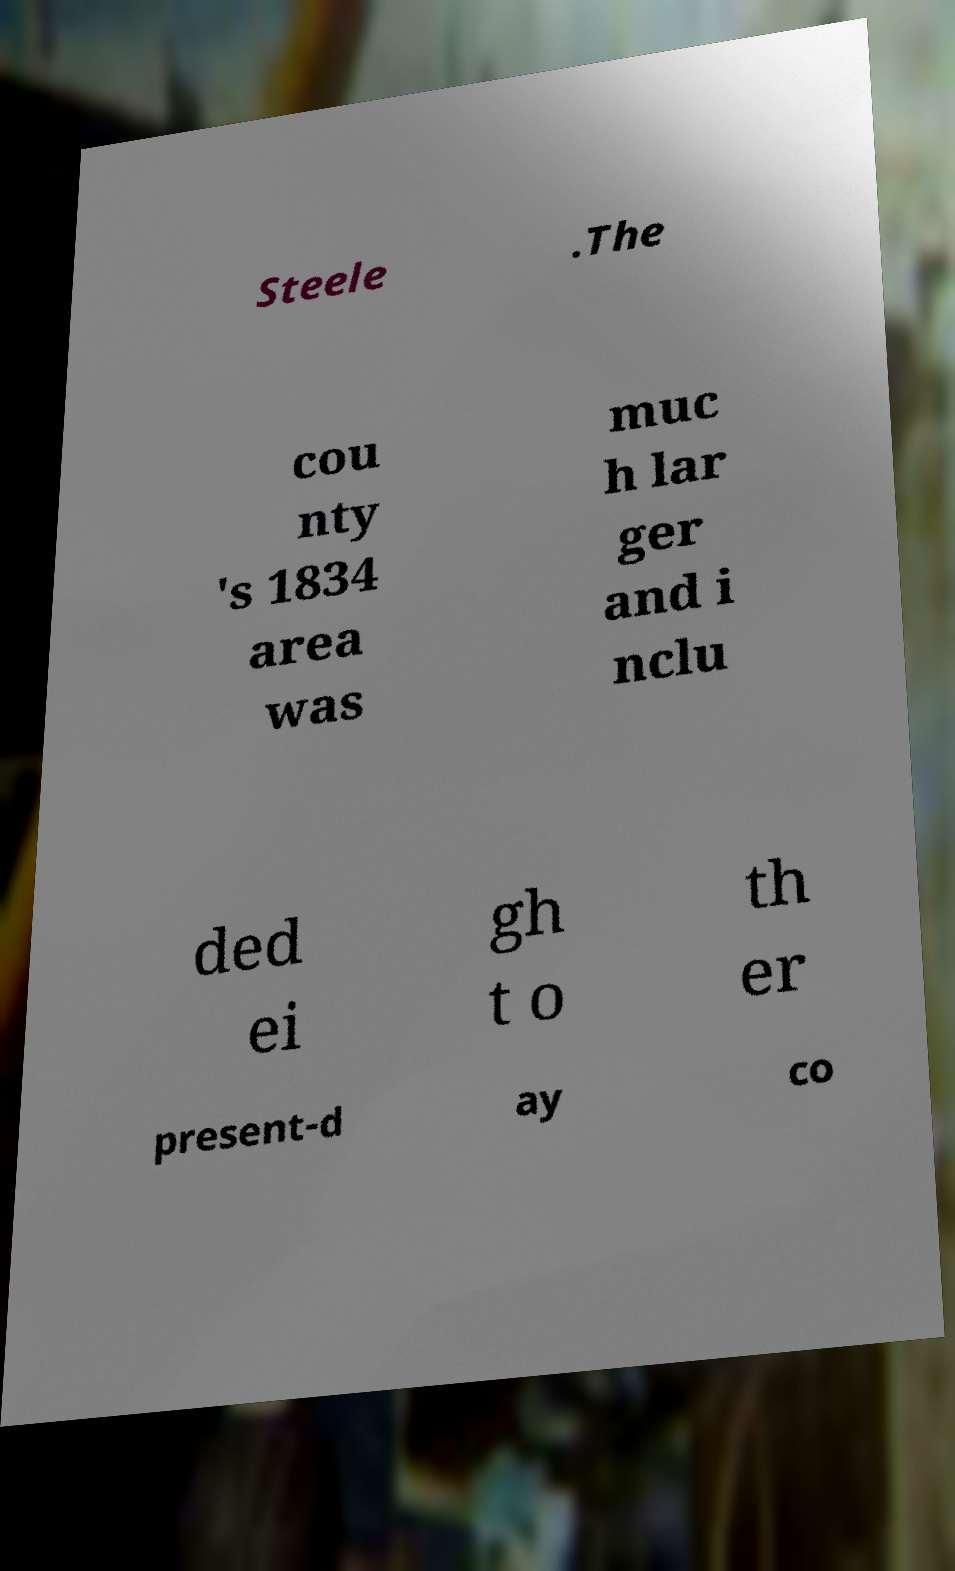Can you accurately transcribe the text from the provided image for me? Steele .The cou nty 's 1834 area was muc h lar ger and i nclu ded ei gh t o th er present-d ay co 